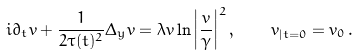<formula> <loc_0><loc_0><loc_500><loc_500>i { \partial } _ { t } v + \frac { 1 } { 2 \tau ( t ) ^ { 2 } } \Delta _ { y } v = \lambda v \ln \left | \frac { v } { \gamma } \right | ^ { 2 } , \quad v _ { | t = 0 } = v _ { 0 } \, .</formula> 